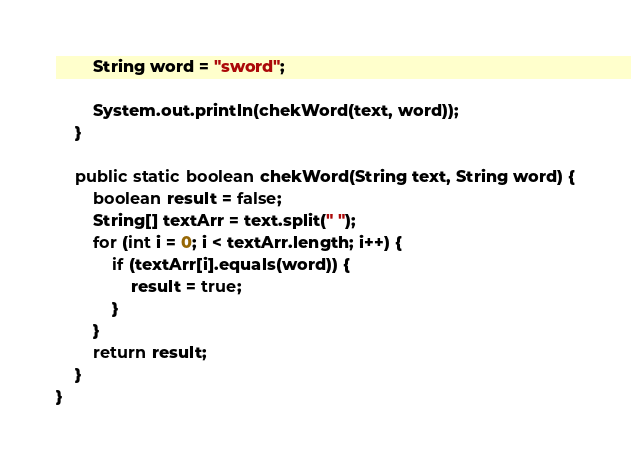Convert code to text. <code><loc_0><loc_0><loc_500><loc_500><_Java_>        String word = "sword";

        System.out.println(chekWord(text, word));
    }

    public static boolean chekWord(String text, String word) {
        boolean result = false;
        String[] textArr = text.split(" ");
        for (int i = 0; i < textArr.length; i++) {
            if (textArr[i].equals(word)) {
                result = true;
            }
        }
        return result;
    }
}
</code> 